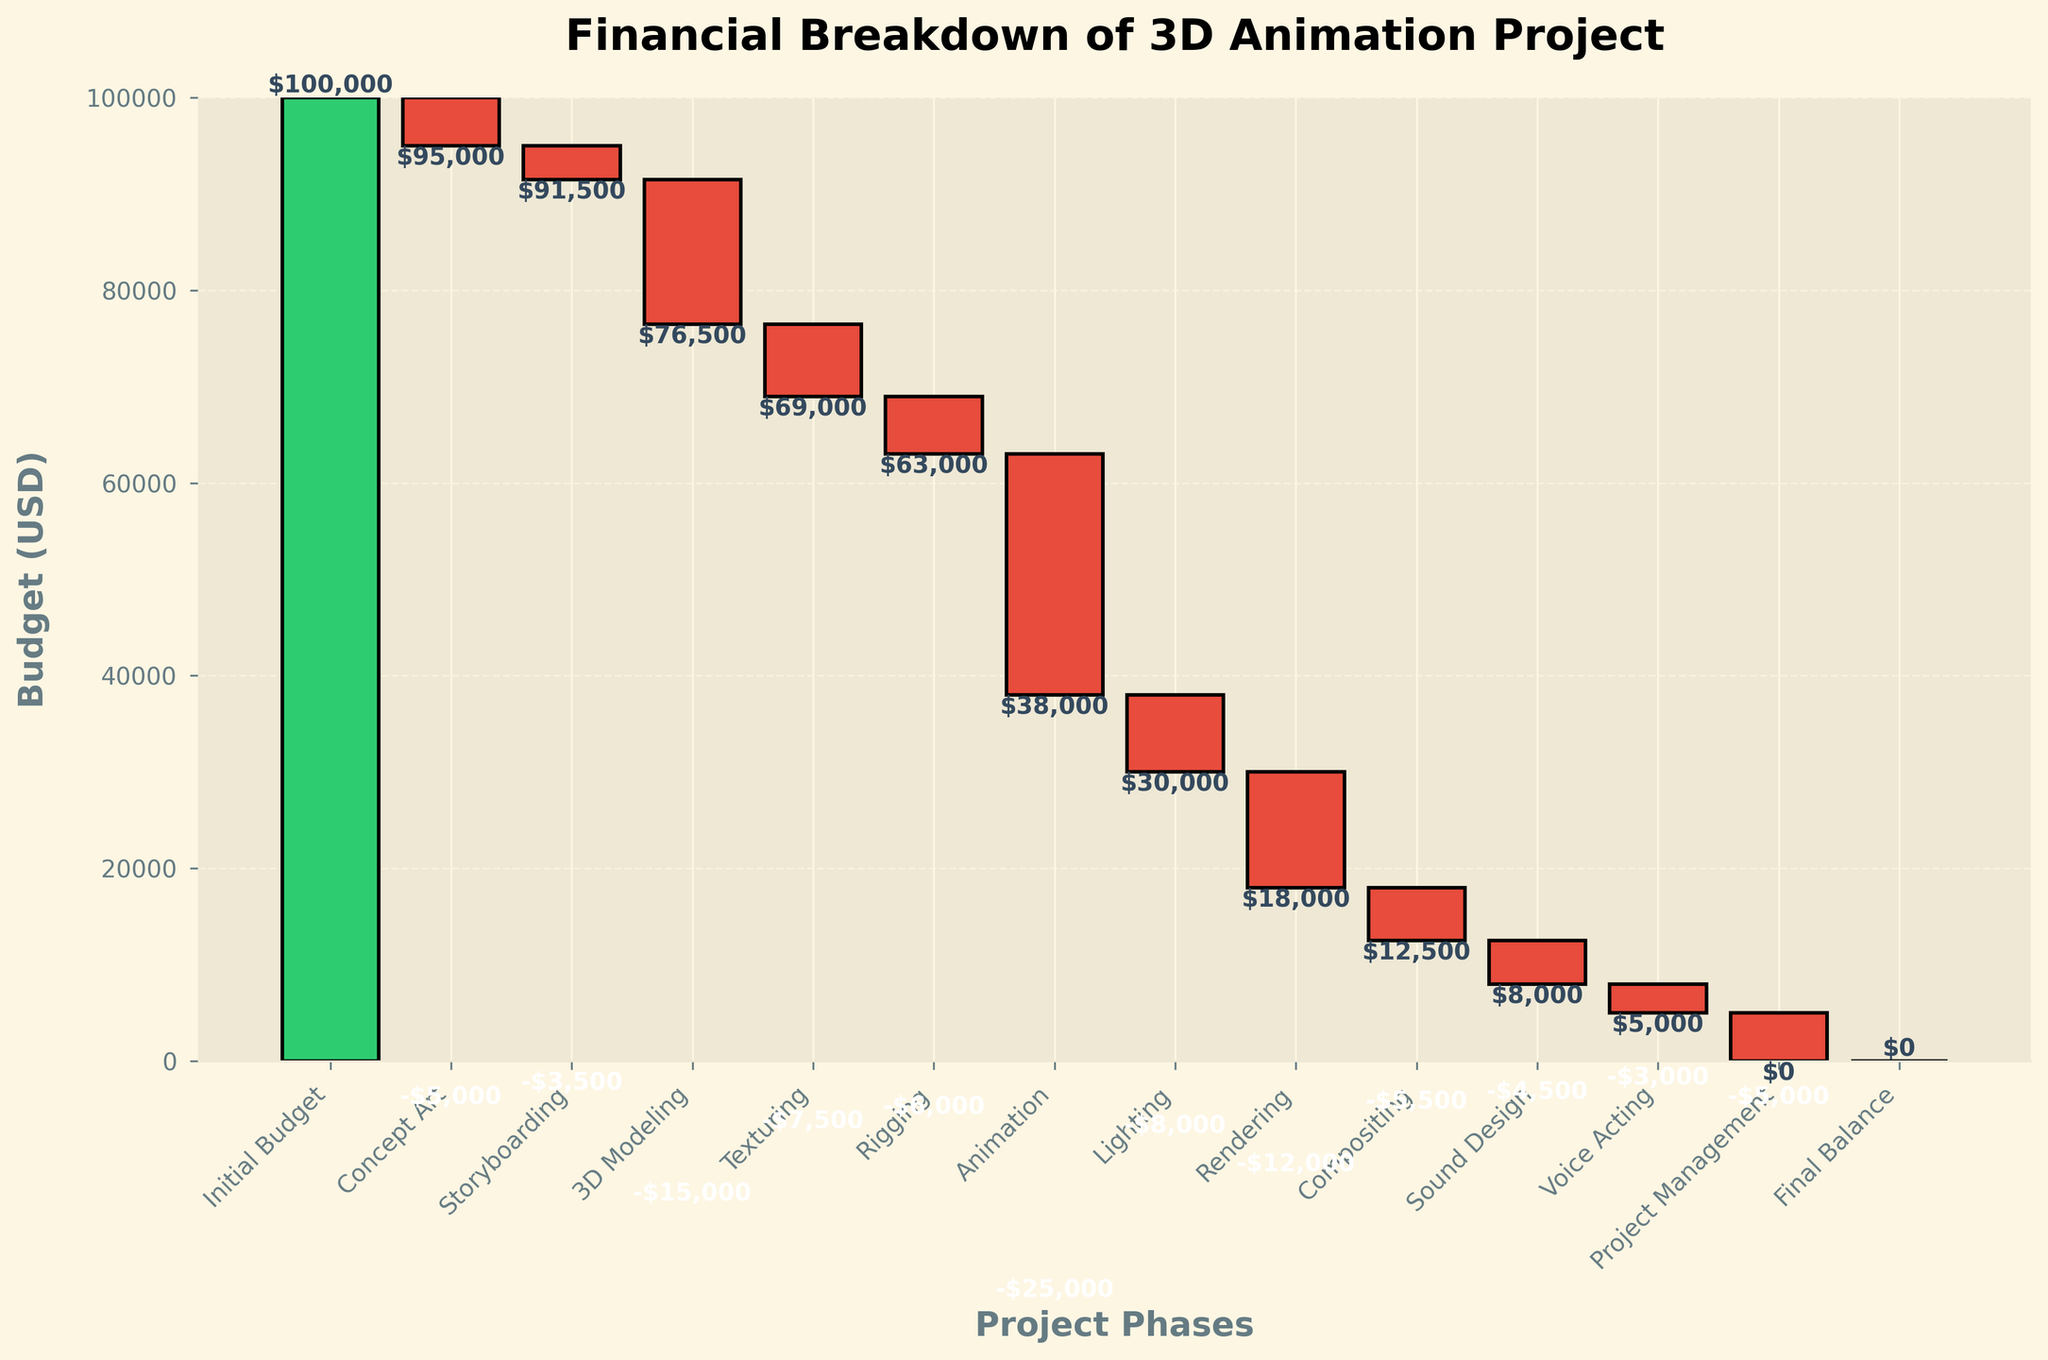What is the title of the figure? The title is prominently displayed at the top of the figure. It states the entirety of the subject in a concise manner.
Answer: Financial Breakdown of 3D Animation Project How many phases are listed in the figure? The categories listed along the x-axis represent the different phases involved in the project. Each bar represents a distinct phase.
Answer: 13 Which phase had the highest expenditure? To determine this, we look at the bars pointing downwards that have the greatest negative values. In this case, it's the Animation phase.
Answer: Animation What is the initial budget allocated to the project? The initial budget is displayed clearly at the beginning of the waterfall chart as a positive bar.
Answer: $100,000 How much was spent on Storyboarding and Rigging together? Sum the expenditures for Storyboarding (-$3,500) and Rigging (-$6,000) together to get the total expenditure for both phases. -$3,500 + -$6,000 = -$9,500
Answer: $9,500 What is the final balance at the end of the project? The final balance is indicated at the end of the waterfall sequence and is normally zero, showcasing that the entire budget has been utilized.
Answer: $0 How do Texturing and Lighting expenditures compare? Identify the bars for Texturing and Lighting, and compare their lengths. Texturing is -$7,500 and Lighting is -$8,000; Lighting has a higher expenditure.
Answer: Lighting has a higher expenditure by $500 What was the total expenditure on Compositing and Sound Design? Add the expenditures for Compositing (-$5,500) and Sound Design (-$4,500) together to find the total: -$5,500 + -$4,500 = -$10,000
Answer: $10,000 How much was left after the Animation phase? To find the balance after the Animation phase, look at the cumulative total just after Animation, which can be found by summing all the previous values including the Animation phase itself.
Answer: $30,000 What is the cumulative expenditure up to Texturing? Calculate the sum of the values from the initial budget to Texturing: 100,000 + -5,000 + -3,500 + -15,000 + -7,500 = $69,000
Answer: $69,000 Which phase had the lowest expenditure and what was the amount? Look for the bar with the smallest negative value, which represents the least amount spent in a phase. Here, it is Voice Acting.
Answer: Voice Acting with $3,000 Is the expenditure on Project Management higher or lower than on Sound Design? Compare the height of the bars for Project Management (-$5,000) and Sound Design (-$4,500). Project Management has a slightly higher expenditure.
Answer: Project Management is higher by $500 